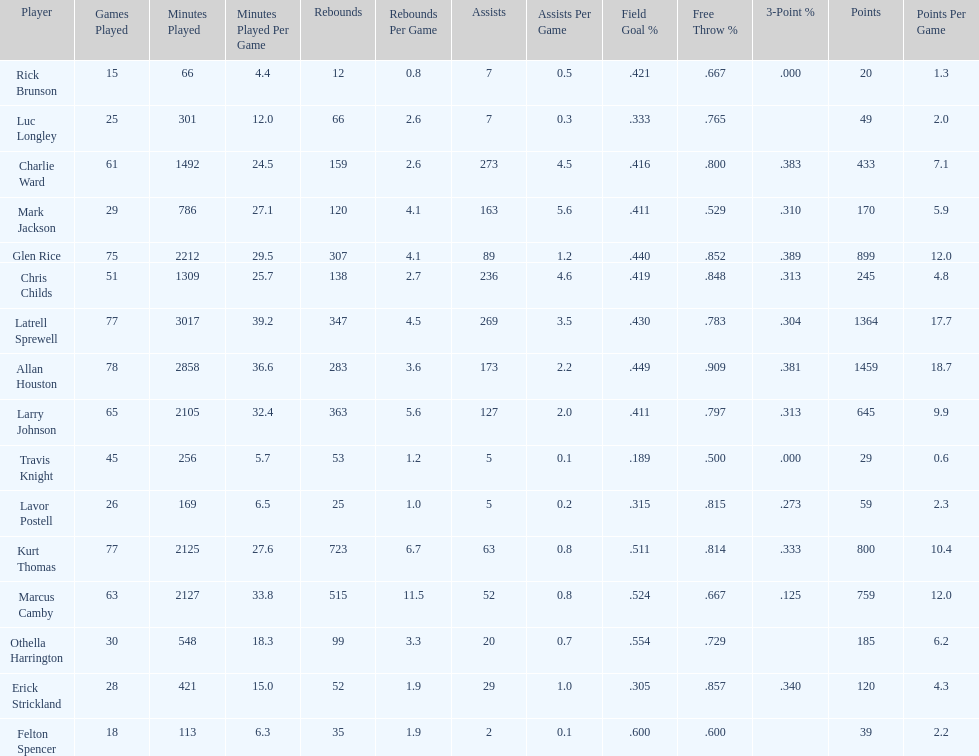How many players had a field goal percentage greater than .500? 4. 